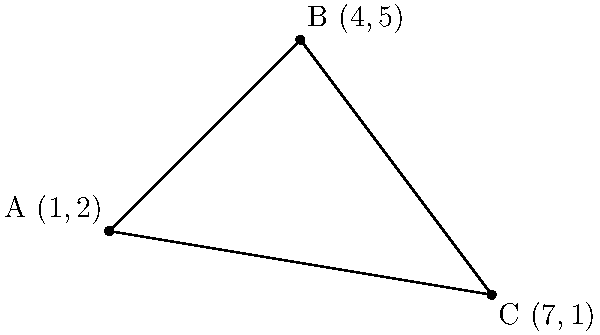In a debate about spatial reasoning, you need to calculate the area of a triangle formed by three points on a coordinate plane. Given the coordinates A(1,2), B(4,5), and C(7,1), determine the area of triangle ABC using the formula:

$$ \text{Area} = \frac{1}{2}|x_1(y_2 - y_3) + x_2(y_3 - y_1) + x_3(y_1 - y_2)| $$

Where $(x_1,y_1)$, $(x_2,y_2)$, and $(x_3,y_3)$ are the coordinates of the three points. To calculate the area of the triangle, we'll use the given formula and follow these steps:

1) Identify the coordinates:
   $(x_1,y_1) = (1,2)$
   $(x_2,y_2) = (4,5)$
   $(x_3,y_3) = (7,1)$

2) Substitute these values into the formula:
   $\text{Area} = \frac{1}{2}|1(5 - 1) + 4(1 - 2) + 7(2 - 5)|$

3) Simplify the expressions inside the parentheses:
   $\text{Area} = \frac{1}{2}|1(4) + 4(-1) + 7(-3)|$

4) Multiply:
   $\text{Area} = \frac{1}{2}|4 - 4 - 21|$

5) Add the terms inside the absolute value signs:
   $\text{Area} = \frac{1}{2}|-21|$

6) Evaluate the absolute value:
   $\text{Area} = \frac{1}{2}(21)$

7) Calculate the final result:
   $\text{Area} = 10.5$

Therefore, the area of the triangle is 10.5 square units.
Answer: 10.5 square units 